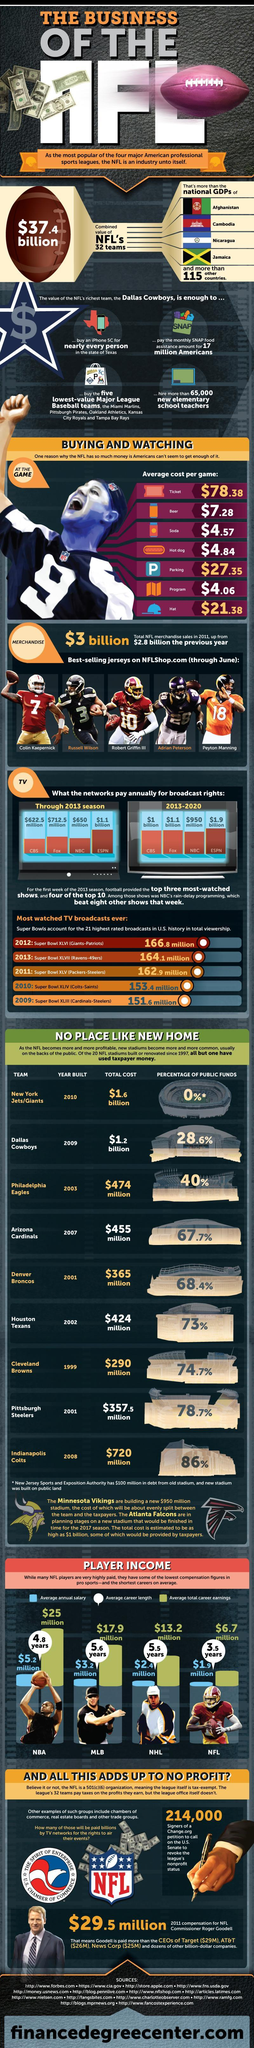Which pro sports players have an average annual salary of $3.2 million?
Answer the question with a short phrase. MLB Which network paid the second highest amount annually for broadcast rights in 2013? Fox In the infographic which NFL player has jersey number 3? Russell Wilson What is the average total career earnings of an NBA player? $25 million What is the jersey number of Peyton Manning? 18 During 2013-2020 which network paid $1.1 billion annually for broadcast rights? Fox During 2013 season which network paid more than $1 billion annually for broadcast rights? ESPN What is the average career length of an NHL player? 5.5 years During 2013-2020 which network paid less than $1 billion annually for broadcast rights? NBC What is the average annual salary of an NFL player? $1.9 million 